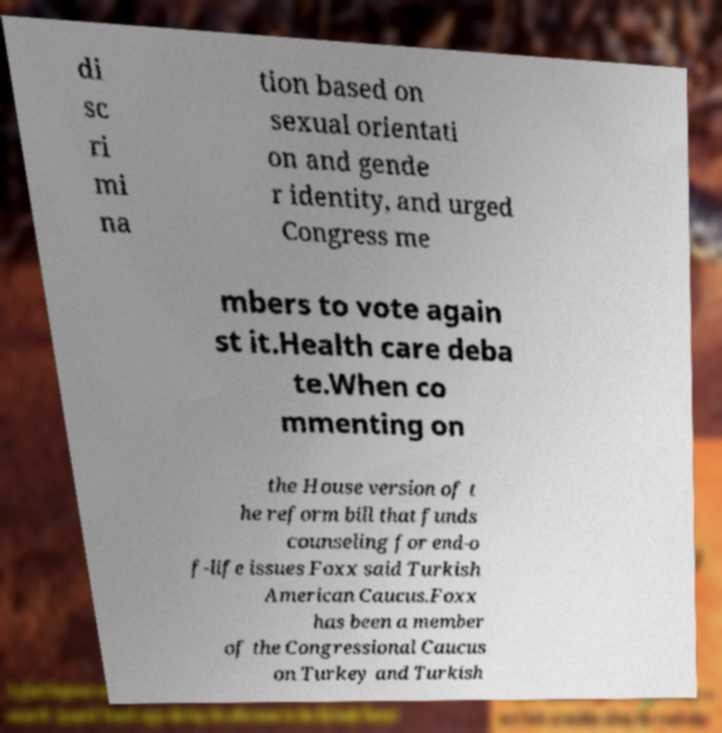I need the written content from this picture converted into text. Can you do that? di sc ri mi na tion based on sexual orientati on and gende r identity, and urged Congress me mbers to vote again st it.Health care deba te.When co mmenting on the House version of t he reform bill that funds counseling for end-o f-life issues Foxx said Turkish American Caucus.Foxx has been a member of the Congressional Caucus on Turkey and Turkish 